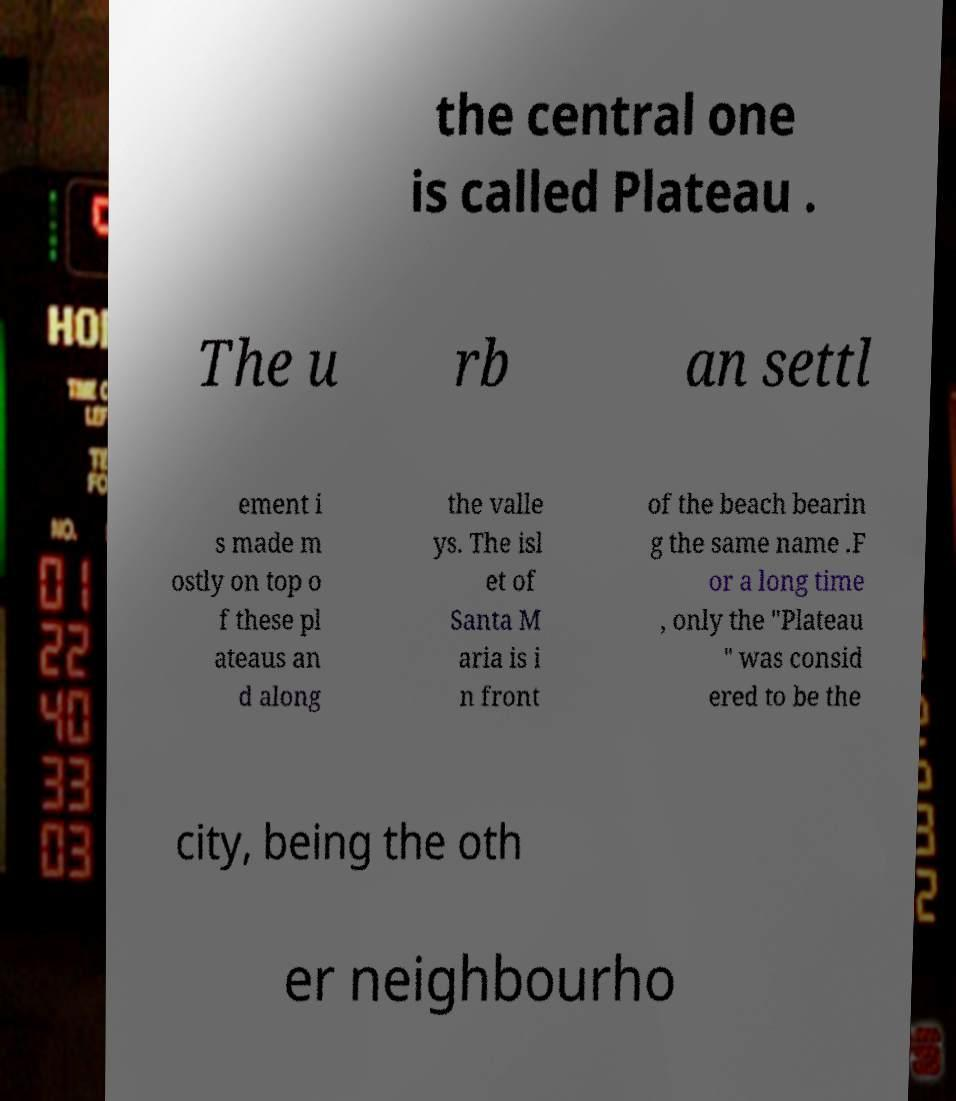Can you read and provide the text displayed in the image?This photo seems to have some interesting text. Can you extract and type it out for me? the central one is called Plateau . The u rb an settl ement i s made m ostly on top o f these pl ateaus an d along the valle ys. The isl et of Santa M aria is i n front of the beach bearin g the same name .F or a long time , only the "Plateau " was consid ered to be the city, being the oth er neighbourho 